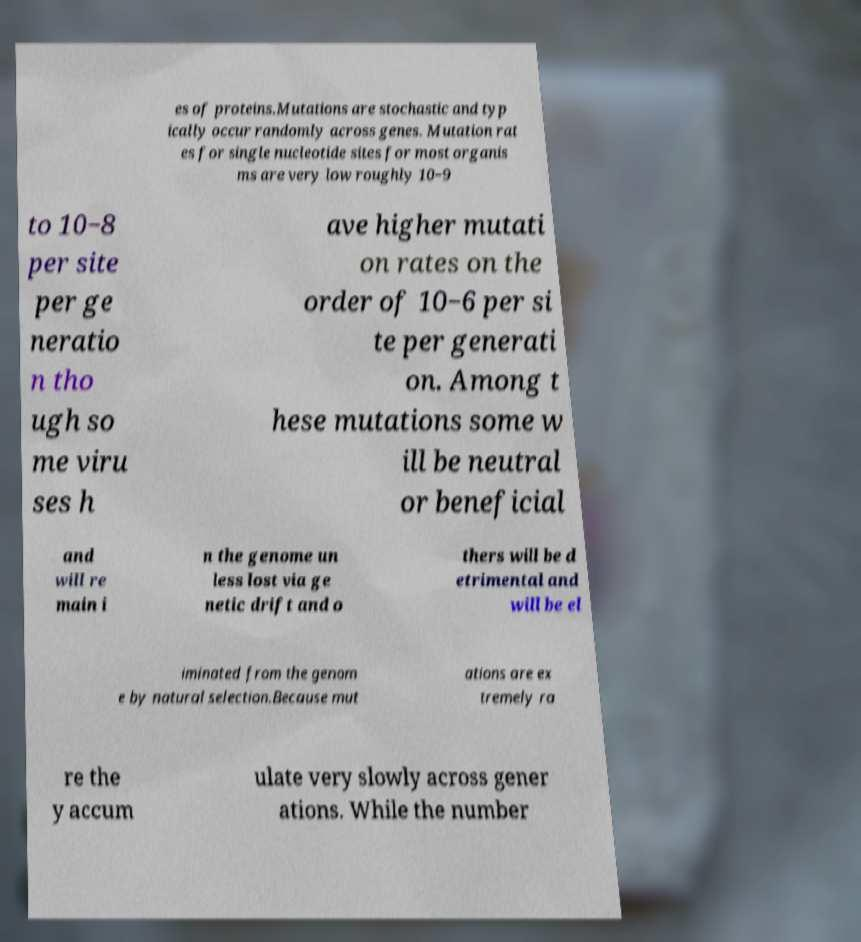There's text embedded in this image that I need extracted. Can you transcribe it verbatim? es of proteins.Mutations are stochastic and typ ically occur randomly across genes. Mutation rat es for single nucleotide sites for most organis ms are very low roughly 10−9 to 10−8 per site per ge neratio n tho ugh so me viru ses h ave higher mutati on rates on the order of 10−6 per si te per generati on. Among t hese mutations some w ill be neutral or beneficial and will re main i n the genome un less lost via ge netic drift and o thers will be d etrimental and will be el iminated from the genom e by natural selection.Because mut ations are ex tremely ra re the y accum ulate very slowly across gener ations. While the number 